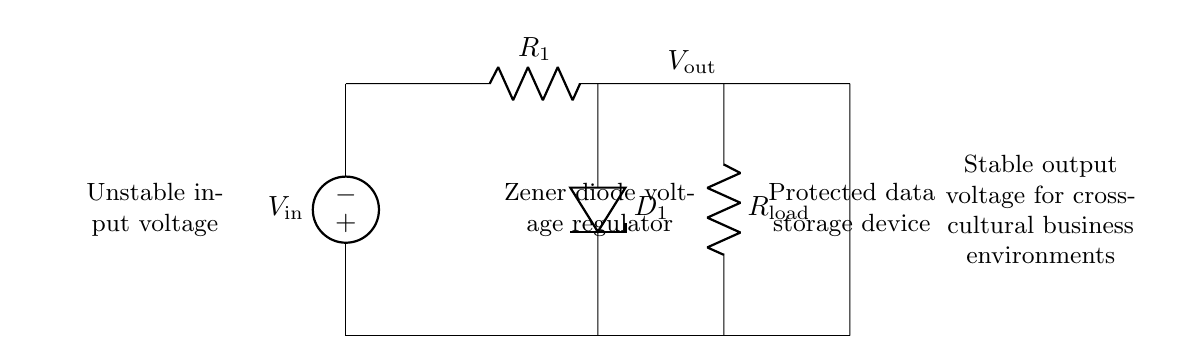What is the component used for voltage regulation? The component used for voltage regulation in this circuit is the Zener diode, labeled as D1. It is designed to maintain a stable output voltage across the load despite variations in the input voltage.
Answer: Zener diode What is the output voltage labeled as in the diagram? The output voltage in the circuit diagram is labeled as Vout, which indicates the stable voltage supplied to the load after regulation by the Zener diode.
Answer: Vout What is the purpose of resistor R1 in this circuit? Resistor R1 is placed in the circuit to limit the current flowing through the Zener diode, preventing it from being damaged by excessive current while still allowing operation in its breakdown region.
Answer: Current limiting What does the term "protected data storage device" refer to? The "protected data storage device" refers to the component or system that requires stabilization of the voltage to ensure proper functionality and prevent data loss from voltage fluctuations.
Answer: Data storage device Why is this circuit crucial for cross-cultural business environments? This circuit is crucial for cross-cultural business environments because it ensures a stable voltage supply which is essential for keeping sensitive data storage devices operational and data secure, especially in areas with unstable power sources.
Answer: Data security 